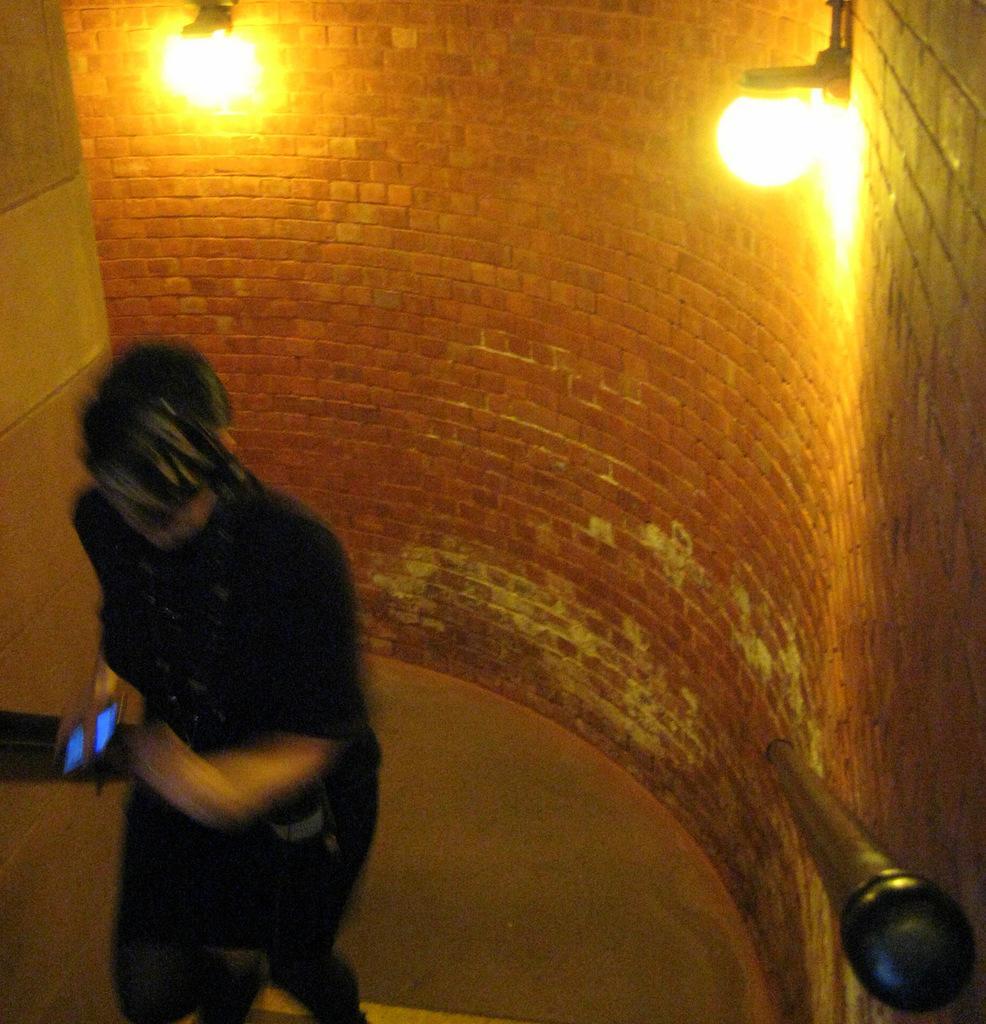Could you give a brief overview of what you see in this image? In this image in the front there is a person holding a mobile phone in hand and on the right side there is a railing and there are lights on the wall. On the left side there is an object which is black in colour and there is a wall. 